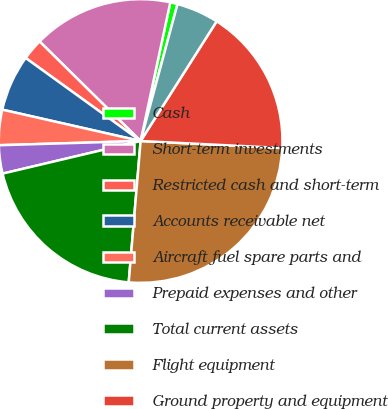Convert chart. <chart><loc_0><loc_0><loc_500><loc_500><pie_chart><fcel>Cash<fcel>Short-term investments<fcel>Restricted cash and short-term<fcel>Accounts receivable net<fcel>Aircraft fuel spare parts and<fcel>Prepaid expenses and other<fcel>Total current assets<fcel>Flight equipment<fcel>Ground property and equipment<fcel>Equipment purchase deposits<nl><fcel>0.83%<fcel>15.98%<fcel>2.42%<fcel>6.41%<fcel>4.02%<fcel>3.22%<fcel>19.97%<fcel>25.55%<fcel>16.78%<fcel>4.82%<nl></chart> 